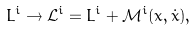<formula> <loc_0><loc_0><loc_500><loc_500>L ^ { i } \rightarrow { \mathcal { L } } ^ { i } = L ^ { i } + { \mathcal { M } } ^ { i } ( x , \dot { x } ) ,</formula> 